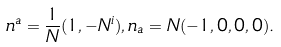<formula> <loc_0><loc_0><loc_500><loc_500>n ^ { a } = \frac { 1 } { N } ( 1 , - N ^ { i } ) , n _ { a } = N ( - 1 , 0 , 0 , 0 ) .</formula> 